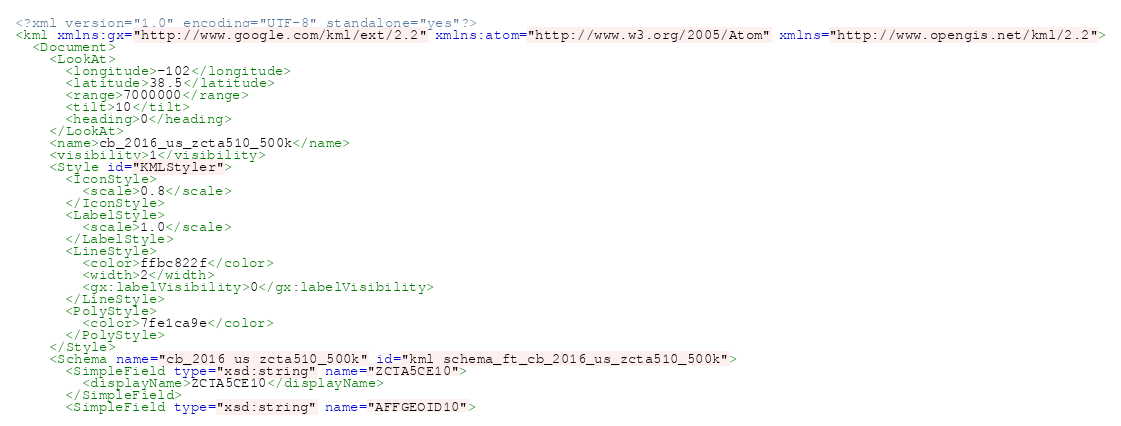<code> <loc_0><loc_0><loc_500><loc_500><_XML_><?xml version="1.0" encoding="UTF-8" standalone="yes"?>
<kml xmlns:gx="http://www.google.com/kml/ext/2.2" xmlns:atom="http://www.w3.org/2005/Atom" xmlns="http://www.opengis.net/kml/2.2">
  <Document>
    <LookAt>
      <longitude>-102</longitude>
      <latitude>38.5</latitude>
      <range>7000000</range>
      <tilt>10</tilt>
      <heading>0</heading>
    </LookAt>
    <name>cb_2016_us_zcta510_500k</name>
    <visibility>1</visibility>
    <Style id="KMLStyler">
      <IconStyle>
        <scale>0.8</scale>
      </IconStyle>
      <LabelStyle>
        <scale>1.0</scale>
      </LabelStyle>
      <LineStyle>
        <color>ffbc822f</color>
        <width>2</width>
        <gx:labelVisibility>0</gx:labelVisibility>
      </LineStyle>
      <PolyStyle>
        <color>7fe1ca9e</color>
      </PolyStyle>
    </Style>
    <Schema name="cb_2016_us_zcta510_500k" id="kml_schema_ft_cb_2016_us_zcta510_500k">
      <SimpleField type="xsd:string" name="ZCTA5CE10">
        <displayName>ZCTA5CE10</displayName>
      </SimpleField>
      <SimpleField type="xsd:string" name="AFFGEOID10"></code> 